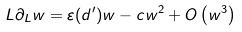<formula> <loc_0><loc_0><loc_500><loc_500>L \partial _ { L } w = \varepsilon ( d ^ { \prime } ) w - c w ^ { 2 } + O \left ( w ^ { 3 } \right )</formula> 